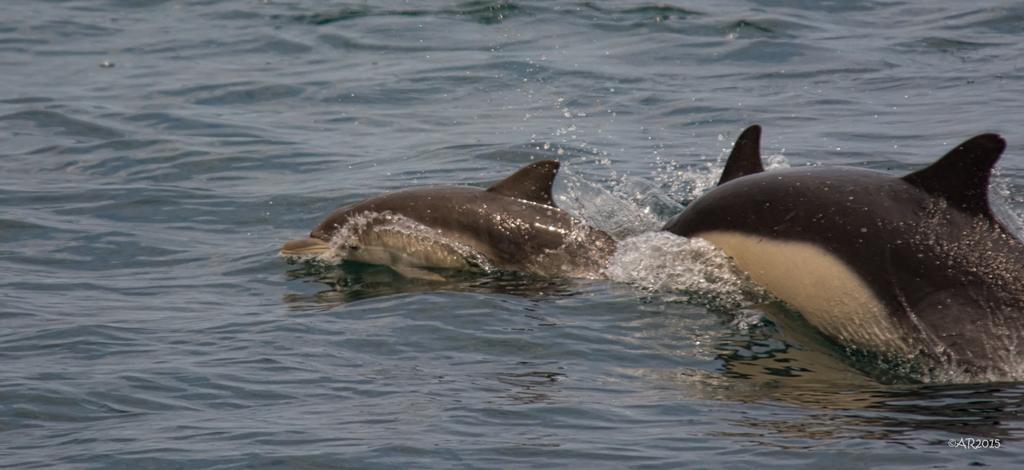In one or two sentences, can you explain what this image depicts? In this picture I can see 2 dolphins in the water and I can see the watermark on the bottom corner of this picture. 